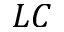<formula> <loc_0><loc_0><loc_500><loc_500>L C</formula> 